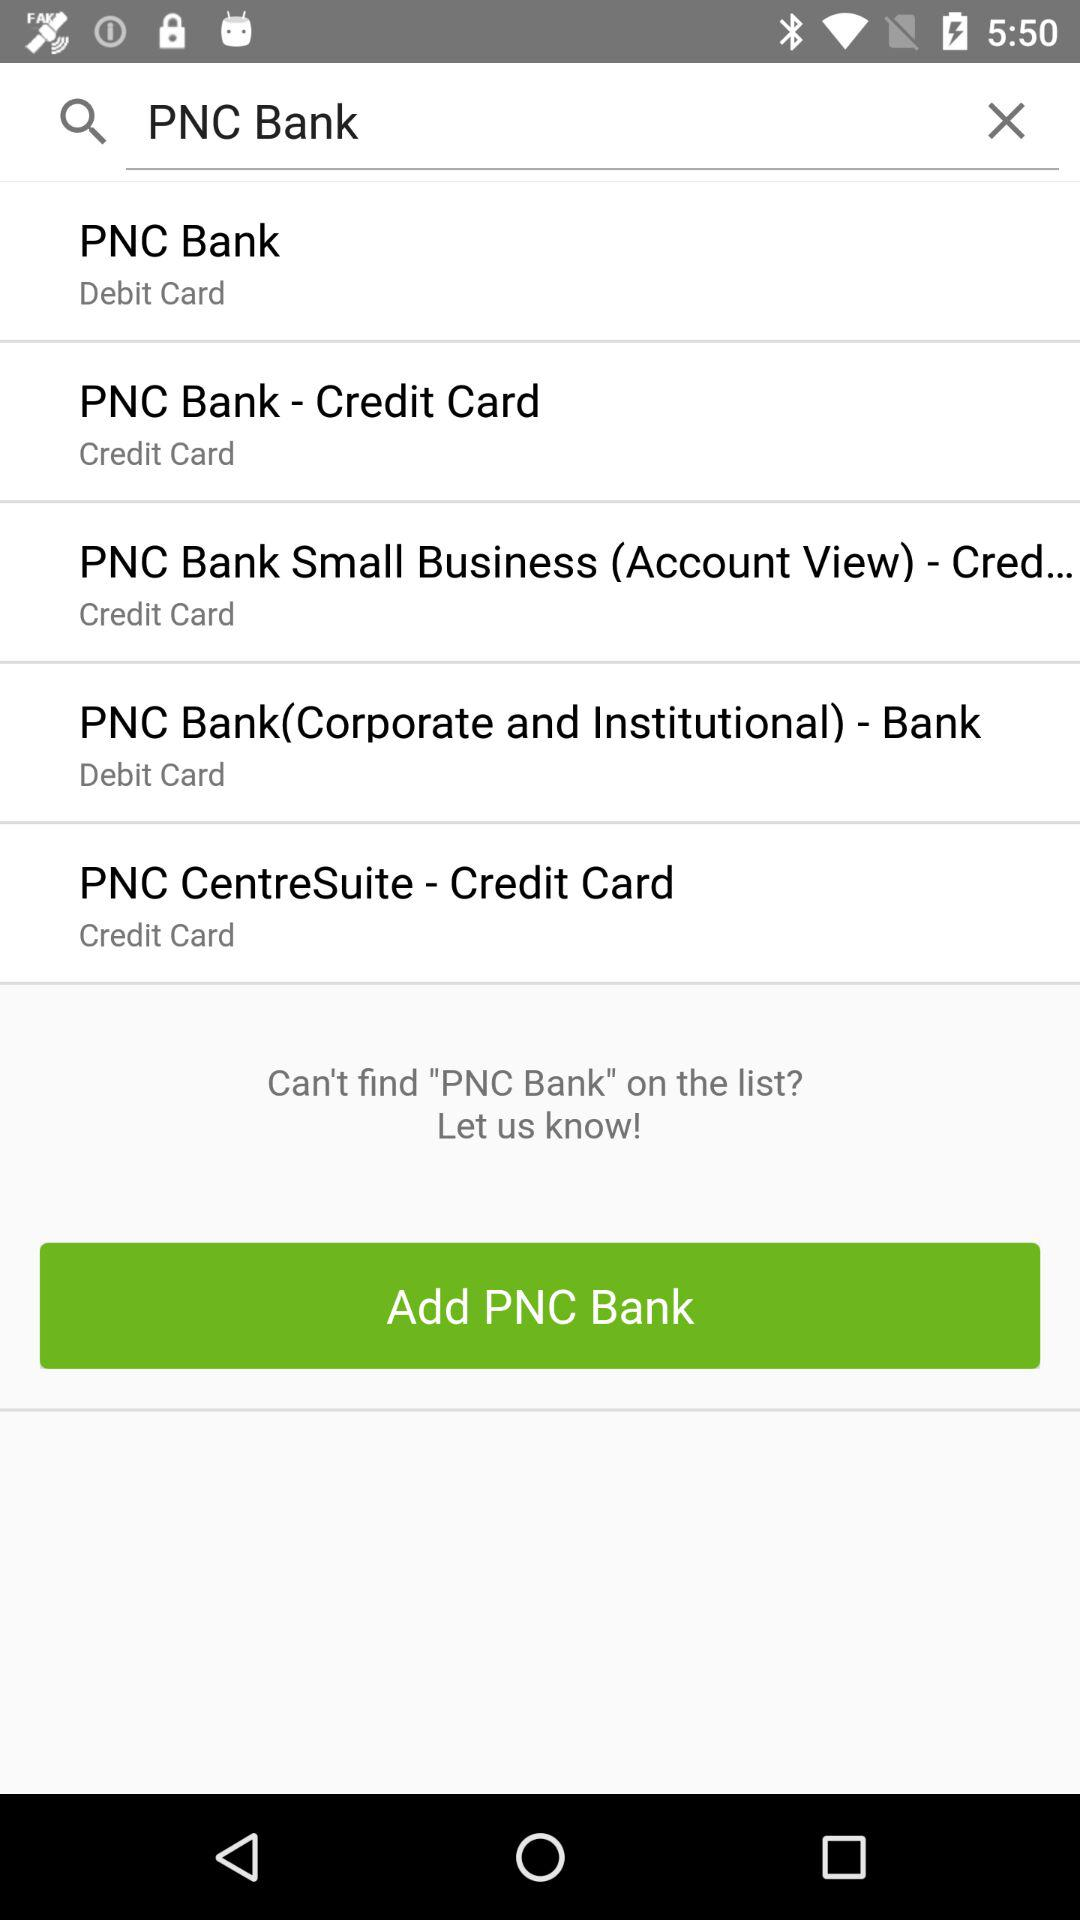What text is input in the input field? The text input is "PNC Bank". 